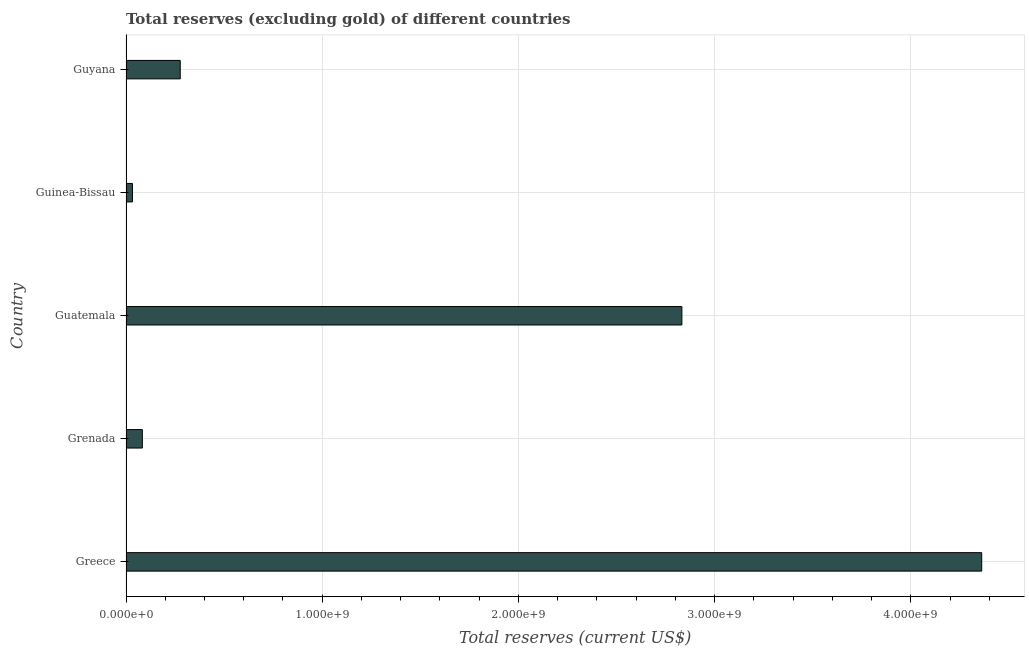Does the graph contain any zero values?
Offer a terse response. No. What is the title of the graph?
Your response must be concise. Total reserves (excluding gold) of different countries. What is the label or title of the X-axis?
Provide a short and direct response. Total reserves (current US$). What is the total reserves (excluding gold) in Grenada?
Offer a terse response. 8.32e+07. Across all countries, what is the maximum total reserves (excluding gold)?
Provide a succinct answer. 4.36e+09. Across all countries, what is the minimum total reserves (excluding gold)?
Provide a short and direct response. 3.29e+07. In which country was the total reserves (excluding gold) maximum?
Provide a succinct answer. Greece. In which country was the total reserves (excluding gold) minimum?
Keep it short and to the point. Guinea-Bissau. What is the sum of the total reserves (excluding gold)?
Your answer should be very brief. 7.59e+09. What is the difference between the total reserves (excluding gold) in Greece and Grenada?
Offer a very short reply. 4.28e+09. What is the average total reserves (excluding gold) per country?
Provide a short and direct response. 1.52e+09. What is the median total reserves (excluding gold)?
Offer a very short reply. 2.76e+08. What is the ratio of the total reserves (excluding gold) in Guatemala to that in Guyana?
Offer a very short reply. 10.25. Is the difference between the total reserves (excluding gold) in Greece and Guyana greater than the difference between any two countries?
Provide a short and direct response. No. What is the difference between the highest and the second highest total reserves (excluding gold)?
Your answer should be very brief. 1.53e+09. Is the sum of the total reserves (excluding gold) in Grenada and Guinea-Bissau greater than the maximum total reserves (excluding gold) across all countries?
Offer a terse response. No. What is the difference between the highest and the lowest total reserves (excluding gold)?
Your response must be concise. 4.33e+09. Are all the bars in the graph horizontal?
Provide a succinct answer. Yes. Are the values on the major ticks of X-axis written in scientific E-notation?
Provide a succinct answer. Yes. What is the Total reserves (current US$) of Greece?
Your answer should be very brief. 4.36e+09. What is the Total reserves (current US$) of Grenada?
Offer a very short reply. 8.32e+07. What is the Total reserves (current US$) of Guatemala?
Give a very brief answer. 2.83e+09. What is the Total reserves (current US$) in Guinea-Bissau?
Ensure brevity in your answer.  3.29e+07. What is the Total reserves (current US$) of Guyana?
Offer a terse response. 2.76e+08. What is the difference between the Total reserves (current US$) in Greece and Grenada?
Provide a succinct answer. 4.28e+09. What is the difference between the Total reserves (current US$) in Greece and Guatemala?
Give a very brief answer. 1.53e+09. What is the difference between the Total reserves (current US$) in Greece and Guinea-Bissau?
Make the answer very short. 4.33e+09. What is the difference between the Total reserves (current US$) in Greece and Guyana?
Offer a terse response. 4.09e+09. What is the difference between the Total reserves (current US$) in Grenada and Guatemala?
Make the answer very short. -2.75e+09. What is the difference between the Total reserves (current US$) in Grenada and Guinea-Bissau?
Your answer should be very brief. 5.03e+07. What is the difference between the Total reserves (current US$) in Grenada and Guyana?
Provide a short and direct response. -1.93e+08. What is the difference between the Total reserves (current US$) in Guatemala and Guinea-Bissau?
Your answer should be compact. 2.80e+09. What is the difference between the Total reserves (current US$) in Guatemala and Guyana?
Give a very brief answer. 2.56e+09. What is the difference between the Total reserves (current US$) in Guinea-Bissau and Guyana?
Provide a short and direct response. -2.43e+08. What is the ratio of the Total reserves (current US$) in Greece to that in Grenada?
Provide a short and direct response. 52.41. What is the ratio of the Total reserves (current US$) in Greece to that in Guatemala?
Your answer should be very brief. 1.54. What is the ratio of the Total reserves (current US$) in Greece to that in Guinea-Bissau?
Offer a terse response. 132.57. What is the ratio of the Total reserves (current US$) in Greece to that in Guyana?
Make the answer very short. 15.78. What is the ratio of the Total reserves (current US$) in Grenada to that in Guatemala?
Your answer should be compact. 0.03. What is the ratio of the Total reserves (current US$) in Grenada to that in Guinea-Bissau?
Offer a terse response. 2.53. What is the ratio of the Total reserves (current US$) in Grenada to that in Guyana?
Your answer should be compact. 0.3. What is the ratio of the Total reserves (current US$) in Guatemala to that in Guinea-Bissau?
Your response must be concise. 86.12. What is the ratio of the Total reserves (current US$) in Guatemala to that in Guyana?
Offer a very short reply. 10.25. What is the ratio of the Total reserves (current US$) in Guinea-Bissau to that in Guyana?
Provide a succinct answer. 0.12. 